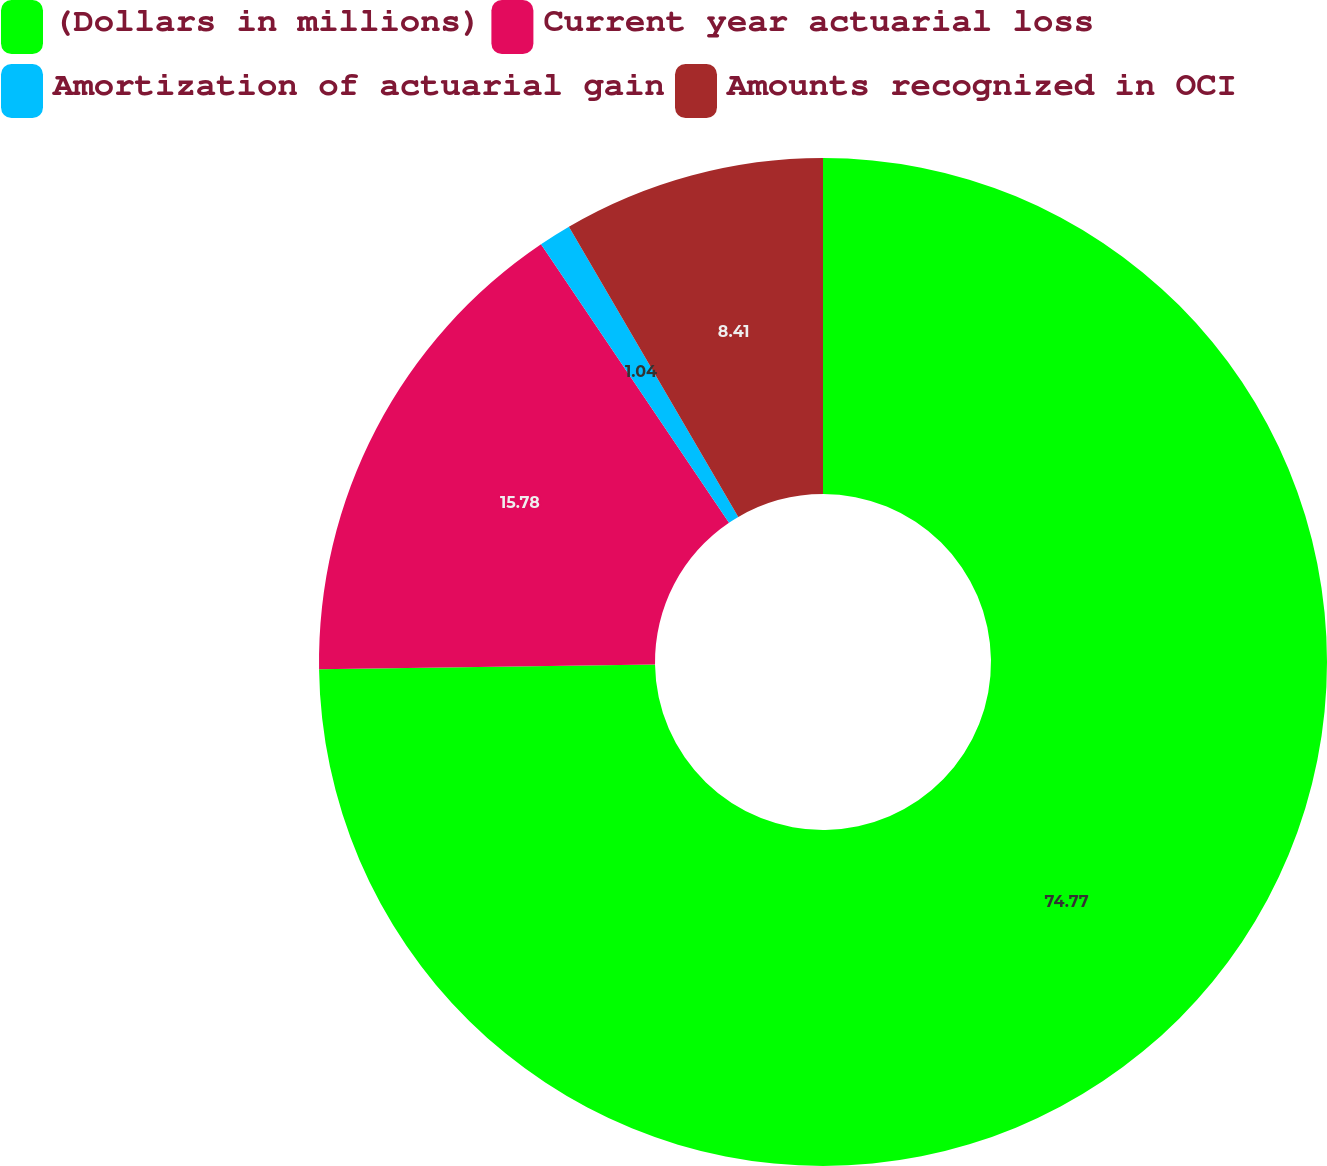<chart> <loc_0><loc_0><loc_500><loc_500><pie_chart><fcel>(Dollars in millions)<fcel>Current year actuarial loss<fcel>Amortization of actuarial gain<fcel>Amounts recognized in OCI<nl><fcel>74.77%<fcel>15.78%<fcel>1.04%<fcel>8.41%<nl></chart> 